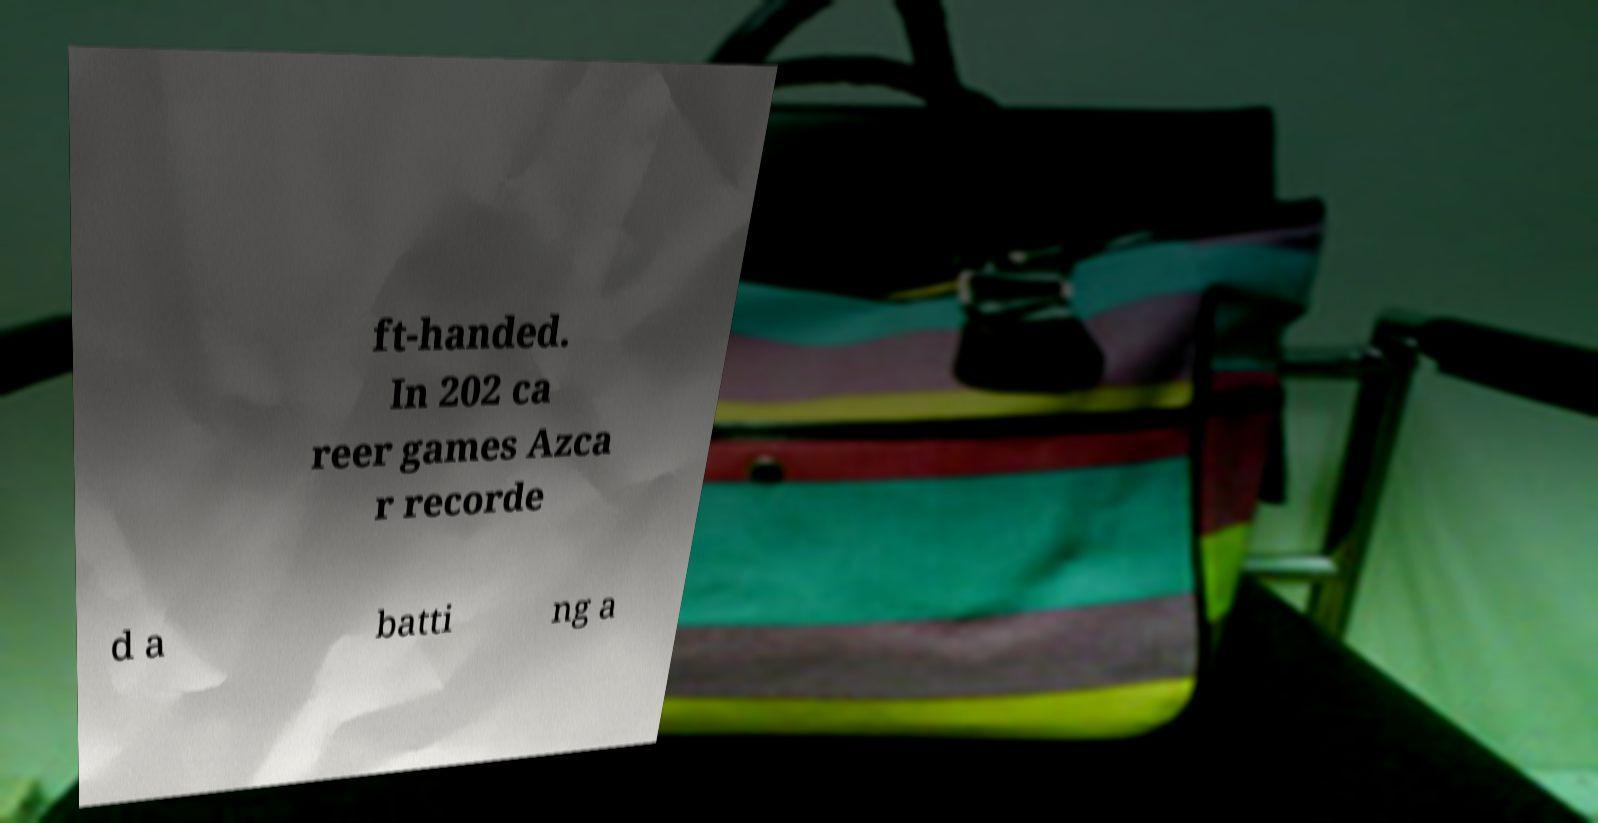What messages or text are displayed in this image? I need them in a readable, typed format. ft-handed. In 202 ca reer games Azca r recorde d a batti ng a 